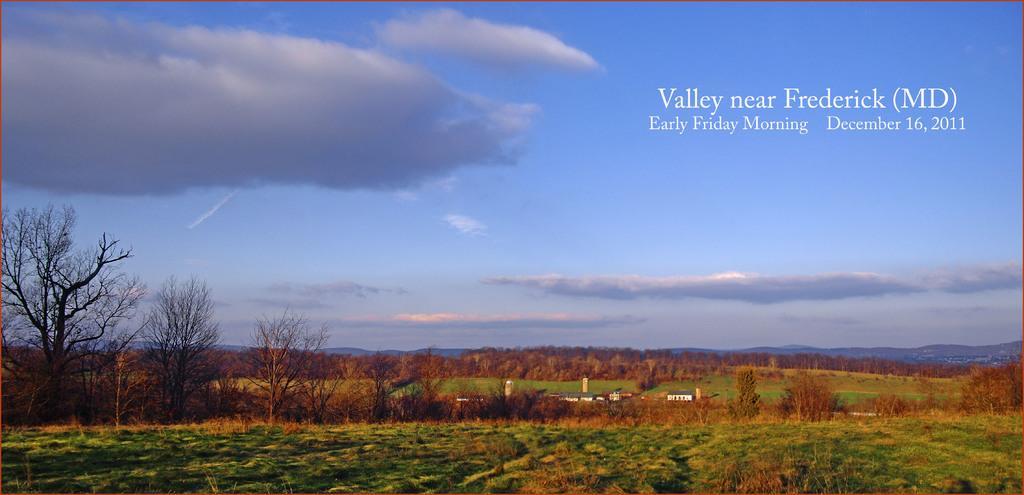Can you describe this image briefly? In this image we can see a group of trees, plants, grass, some buildings, the hills and the sky which looks cloudy. We can also see some text on this image. 